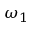Convert formula to latex. <formula><loc_0><loc_0><loc_500><loc_500>\omega _ { 1 }</formula> 